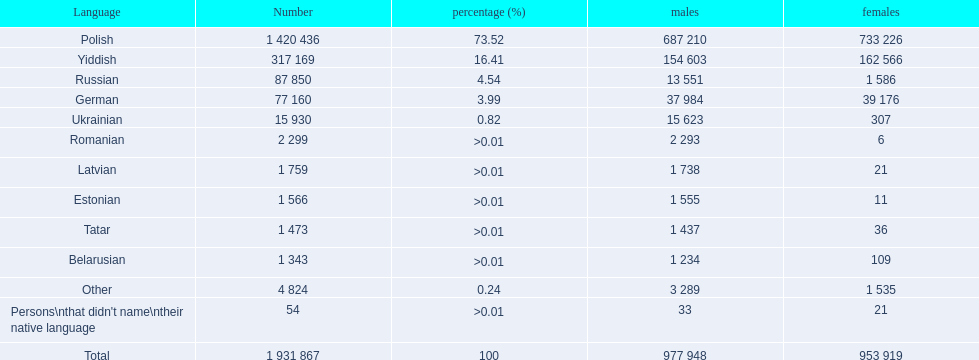Which languages have more than 50,000 speakers? Polish, Yiddish, Russian, German. From those, which are spoken by fewer than 15% of people? Russian, German. Among the final two, which one has 37,984 men speaking it? German. Can you parse all the data within this table? {'header': ['Language', 'Number', 'percentage (%)', 'males', 'females'], 'rows': [['Polish', '1 420 436', '73.52', '687 210', '733 226'], ['Yiddish', '317 169', '16.41', '154 603', '162 566'], ['Russian', '87 850', '4.54', '13 551', '1 586'], ['German', '77 160', '3.99', '37 984', '39 176'], ['Ukrainian', '15 930', '0.82', '15 623', '307'], ['Romanian', '2 299', '>0.01', '2 293', '6'], ['Latvian', '1 759', '>0.01', '1 738', '21'], ['Estonian', '1 566', '>0.01', '1 555', '11'], ['Tatar', '1 473', '>0.01', '1 437', '36'], ['Belarusian', '1 343', '>0.01', '1 234', '109'], ['Other', '4 824', '0.24', '3 289', '1 535'], ["Persons\\nthat didn't name\\ntheir native language", '54', '>0.01', '33', '21'], ['Total', '1 931 867', '100', '977 948', '953 919']]} 